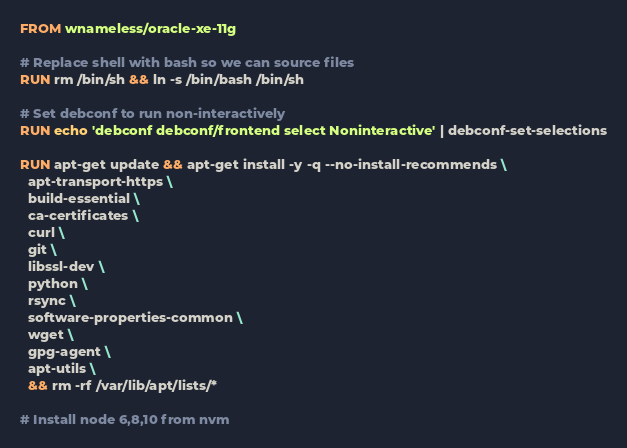Convert code to text. <code><loc_0><loc_0><loc_500><loc_500><_Dockerfile_>FROM wnameless/oracle-xe-11g

# Replace shell with bash so we can source files
RUN rm /bin/sh && ln -s /bin/bash /bin/sh

# Set debconf to run non-interactively
RUN echo 'debconf debconf/frontend select Noninteractive' | debconf-set-selections

RUN apt-get update && apt-get install -y -q --no-install-recommends \
  apt-transport-https \
  build-essential \
  ca-certificates \
  curl \
  git \
  libssl-dev \
  python \
  rsync \
  software-properties-common \
  wget \
  gpg-agent \
  apt-utils \
  && rm -rf /var/lib/apt/lists/*

# Install node 6,8,10 from nvm</code> 